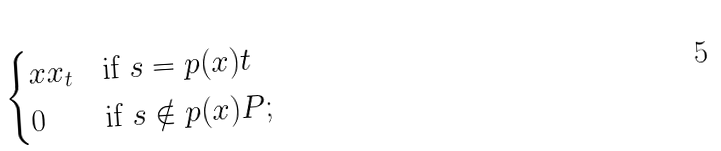<formula> <loc_0><loc_0><loc_500><loc_500>\begin{cases} x x _ { t } & \text {if $s = p(x)t$} \\ 0 & \text {if $s\notin p(x)P$;} \end{cases}</formula> 